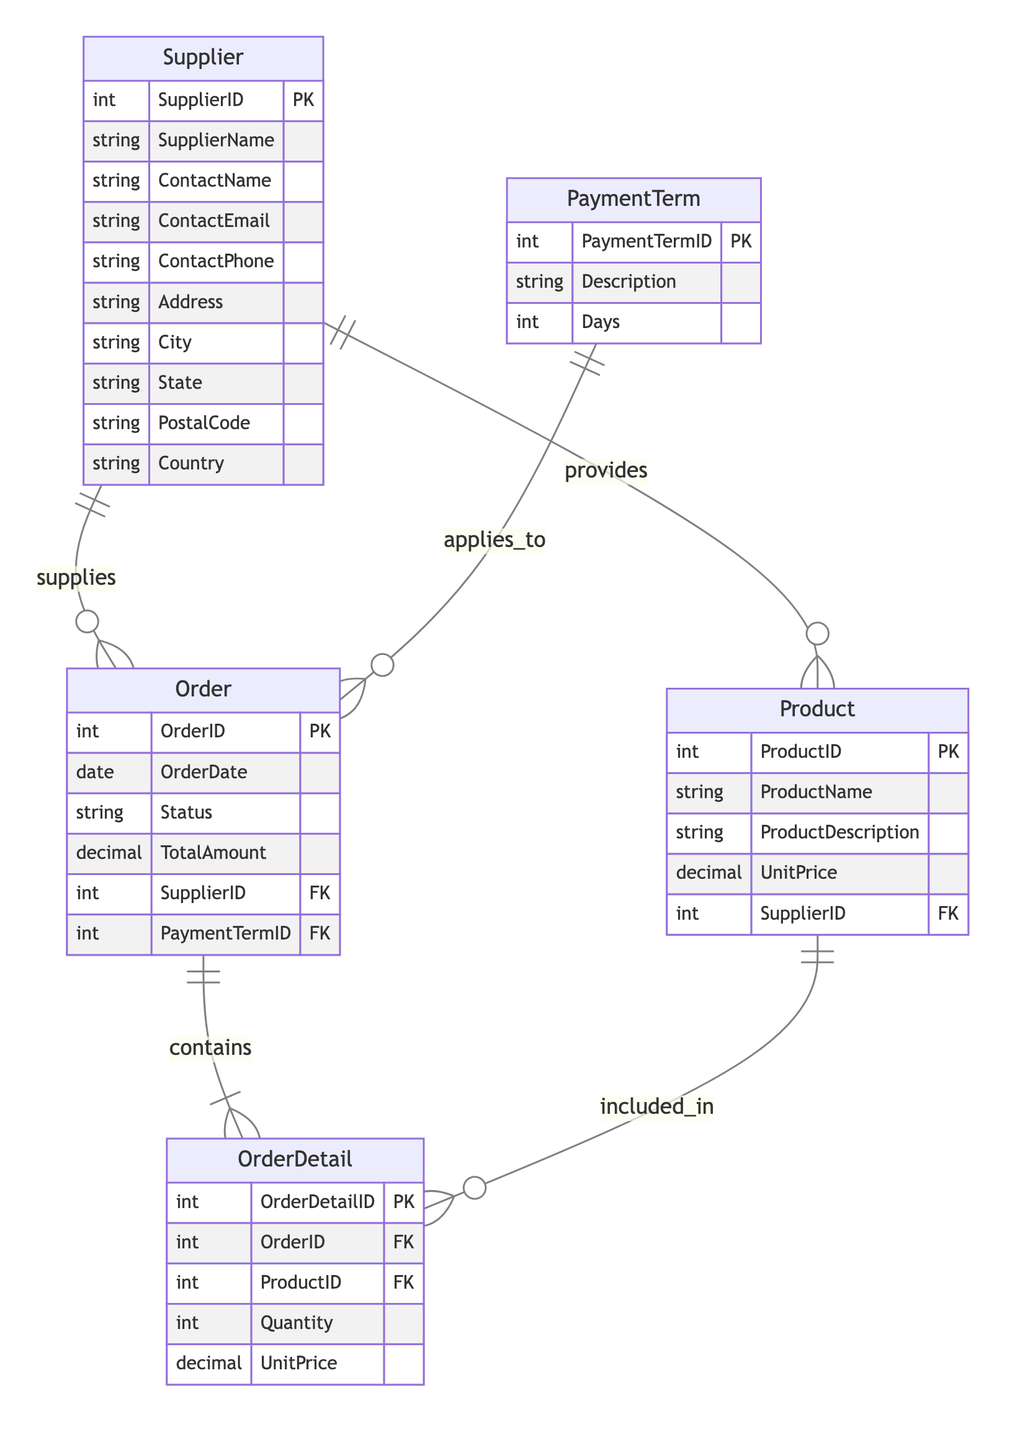What is the primary key of the Supplier entity? The primary key for the Supplier entity is SupplierID, which uniquely identifies each supplier in the database.
Answer: SupplierID How many attributes does the Product entity have? The Product entity has five attributes: ProductID, ProductName, ProductDescription, UnitPrice, and SupplierID.
Answer: Five Which entity has a one-to-many relationship with Order? The Supplier entity has a one-to-many relationship with the Order entity, indicating that one supplier can supply multiple orders.
Answer: Supplier What kind of relationship exists between Order and OrderDetail? The relationship between Order and OrderDetail is one-to-many, meaning a single order can contain multiple order details.
Answer: One-to-many How many entities are involved in the diagram? There are five entities in the diagram: Supplier, Order, PaymentTerm, OrderDetail, and Product.
Answer: Five Which foreign key is present in the Order entity? The foreign keys present in the Order entity are SupplierID and PaymentTermID, linking it to the Supplier and PaymentTerm entities respectively.
Answer: SupplierID and PaymentTermID What relationship does PaymentTerm have with Order? PaymentTerm has a one-to-many relationship with Order, indicating that one payment term can apply to multiple orders.
Answer: One-to-many How many different products can a single supplier provide? A single supplier can provide multiple products, as indicated by the many-to-one relationship between Product and Supplier. The exact count depends on the data but each supplier can supply many products.
Answer: Many Which entity's primary key is referenced in the OrderDetail entity? The primary keys referenced in the OrderDetail entity are OrderID, which links to the Order entity, and ProductID, which links to the Product entity.
Answer: OrderID and ProductID 